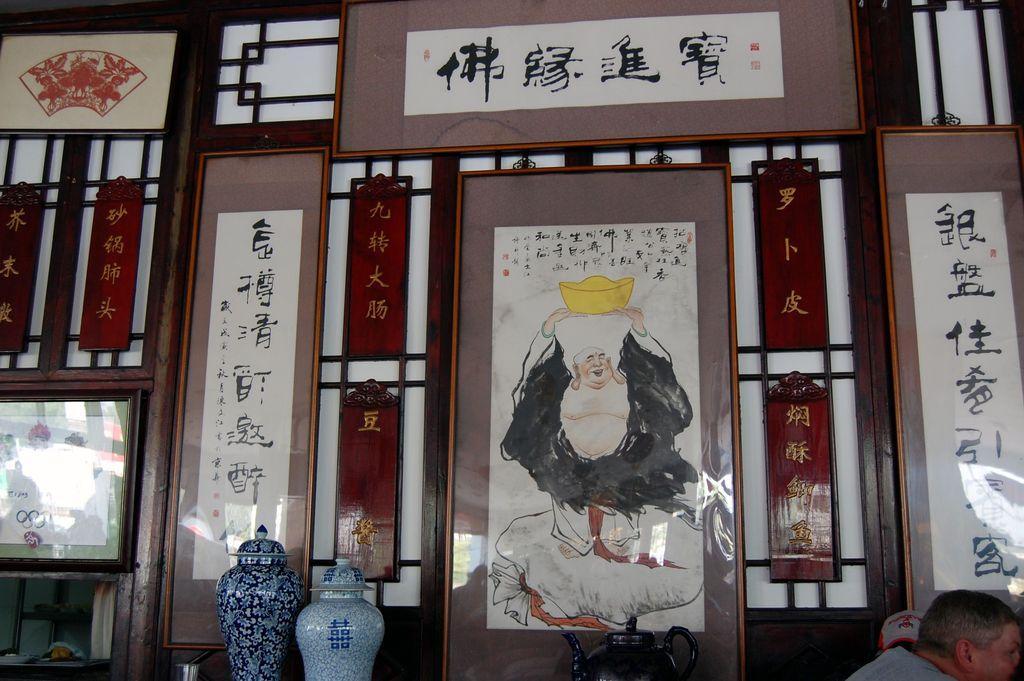In one or two sentences, can you explain what this image depicts? In this image I can see few frames in different color. I can see two bases which are in blue color and I can see a person. 